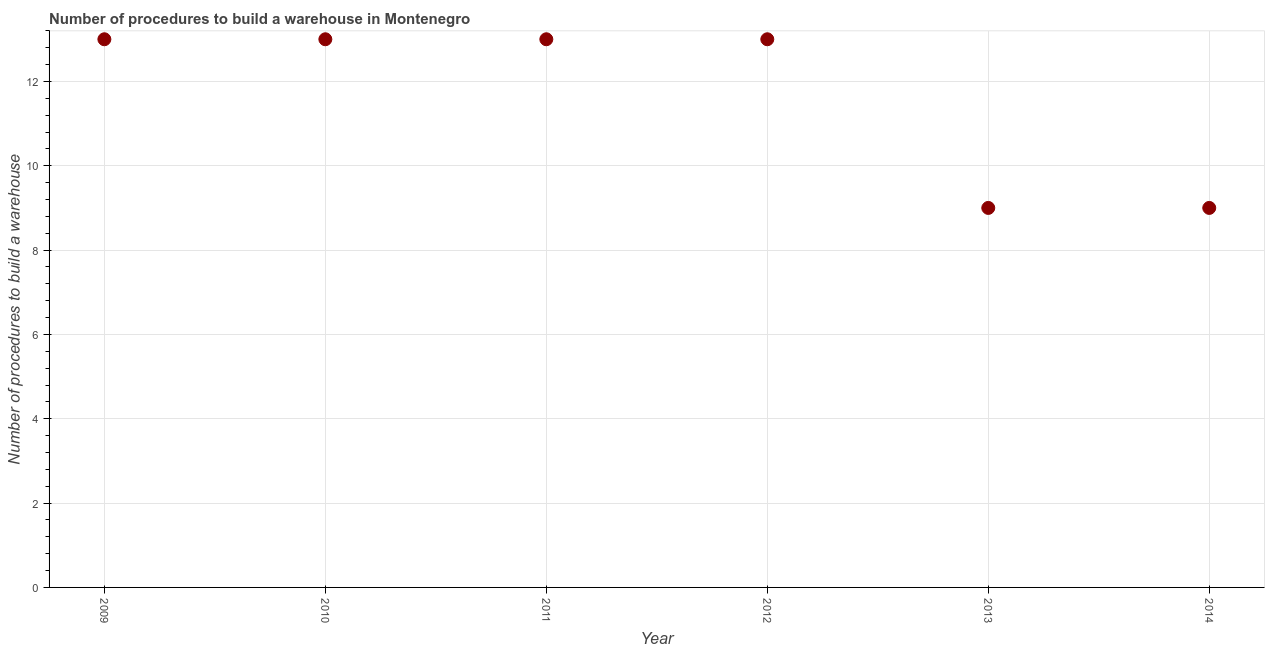What is the number of procedures to build a warehouse in 2013?
Offer a very short reply. 9. Across all years, what is the maximum number of procedures to build a warehouse?
Your answer should be compact. 13. Across all years, what is the minimum number of procedures to build a warehouse?
Give a very brief answer. 9. In which year was the number of procedures to build a warehouse minimum?
Your answer should be compact. 2013. What is the sum of the number of procedures to build a warehouse?
Provide a succinct answer. 70. What is the difference between the number of procedures to build a warehouse in 2010 and 2011?
Your response must be concise. 0. What is the average number of procedures to build a warehouse per year?
Your answer should be compact. 11.67. In how many years, is the number of procedures to build a warehouse greater than 0.8 ?
Give a very brief answer. 6. Do a majority of the years between 2011 and 2013 (inclusive) have number of procedures to build a warehouse greater than 10.4 ?
Ensure brevity in your answer.  Yes. What is the ratio of the number of procedures to build a warehouse in 2011 to that in 2013?
Provide a succinct answer. 1.44. Is the difference between the number of procedures to build a warehouse in 2010 and 2012 greater than the difference between any two years?
Make the answer very short. No. What is the difference between the highest and the lowest number of procedures to build a warehouse?
Your answer should be very brief. 4. In how many years, is the number of procedures to build a warehouse greater than the average number of procedures to build a warehouse taken over all years?
Your response must be concise. 4. Does the number of procedures to build a warehouse monotonically increase over the years?
Give a very brief answer. No. Are the values on the major ticks of Y-axis written in scientific E-notation?
Your answer should be very brief. No. Does the graph contain grids?
Give a very brief answer. Yes. What is the title of the graph?
Make the answer very short. Number of procedures to build a warehouse in Montenegro. What is the label or title of the X-axis?
Offer a very short reply. Year. What is the label or title of the Y-axis?
Your answer should be compact. Number of procedures to build a warehouse. What is the Number of procedures to build a warehouse in 2009?
Your response must be concise. 13. What is the Number of procedures to build a warehouse in 2010?
Your answer should be very brief. 13. What is the difference between the Number of procedures to build a warehouse in 2009 and 2010?
Your answer should be very brief. 0. What is the difference between the Number of procedures to build a warehouse in 2009 and 2012?
Your response must be concise. 0. What is the difference between the Number of procedures to build a warehouse in 2009 and 2013?
Your answer should be compact. 4. What is the difference between the Number of procedures to build a warehouse in 2010 and 2011?
Your response must be concise. 0. What is the difference between the Number of procedures to build a warehouse in 2010 and 2012?
Give a very brief answer. 0. What is the difference between the Number of procedures to build a warehouse in 2010 and 2013?
Your response must be concise. 4. What is the difference between the Number of procedures to build a warehouse in 2011 and 2013?
Make the answer very short. 4. What is the difference between the Number of procedures to build a warehouse in 2011 and 2014?
Your answer should be very brief. 4. What is the ratio of the Number of procedures to build a warehouse in 2009 to that in 2010?
Your answer should be very brief. 1. What is the ratio of the Number of procedures to build a warehouse in 2009 to that in 2012?
Provide a succinct answer. 1. What is the ratio of the Number of procedures to build a warehouse in 2009 to that in 2013?
Offer a very short reply. 1.44. What is the ratio of the Number of procedures to build a warehouse in 2009 to that in 2014?
Offer a terse response. 1.44. What is the ratio of the Number of procedures to build a warehouse in 2010 to that in 2013?
Your response must be concise. 1.44. What is the ratio of the Number of procedures to build a warehouse in 2010 to that in 2014?
Make the answer very short. 1.44. What is the ratio of the Number of procedures to build a warehouse in 2011 to that in 2012?
Your answer should be very brief. 1. What is the ratio of the Number of procedures to build a warehouse in 2011 to that in 2013?
Provide a short and direct response. 1.44. What is the ratio of the Number of procedures to build a warehouse in 2011 to that in 2014?
Provide a short and direct response. 1.44. What is the ratio of the Number of procedures to build a warehouse in 2012 to that in 2013?
Provide a short and direct response. 1.44. What is the ratio of the Number of procedures to build a warehouse in 2012 to that in 2014?
Keep it short and to the point. 1.44. What is the ratio of the Number of procedures to build a warehouse in 2013 to that in 2014?
Your answer should be compact. 1. 